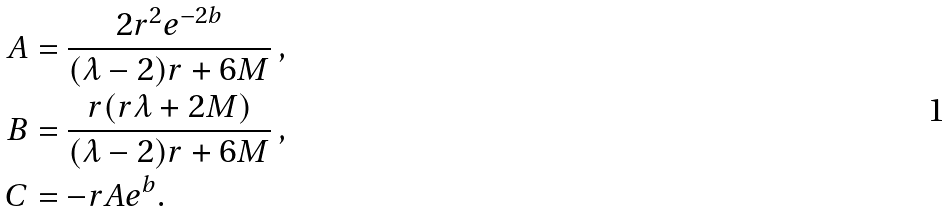<formula> <loc_0><loc_0><loc_500><loc_500>A & = \frac { 2 r ^ { 2 } e ^ { - 2 b } } { ( \lambda - 2 ) r + 6 M } \, , \\ B & = \frac { r ( r \lambda + 2 M ) } { ( \lambda - 2 ) r + 6 M } \, , \\ C & = - r A e ^ { b } .</formula> 